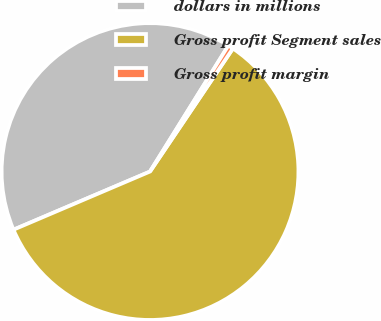<chart> <loc_0><loc_0><loc_500><loc_500><pie_chart><fcel>dollars in millions<fcel>Gross profit Segment sales<fcel>Gross profit margin<nl><fcel>40.26%<fcel>59.15%<fcel>0.58%<nl></chart> 